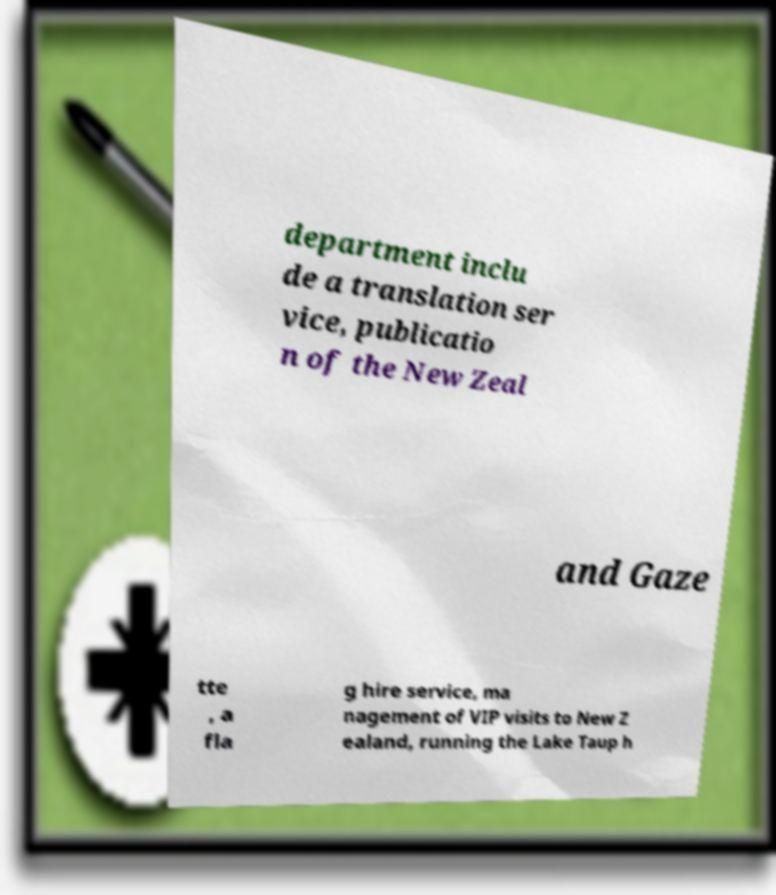For documentation purposes, I need the text within this image transcribed. Could you provide that? department inclu de a translation ser vice, publicatio n of the New Zeal and Gaze tte , a fla g hire service, ma nagement of VIP visits to New Z ealand, running the Lake Taup h 